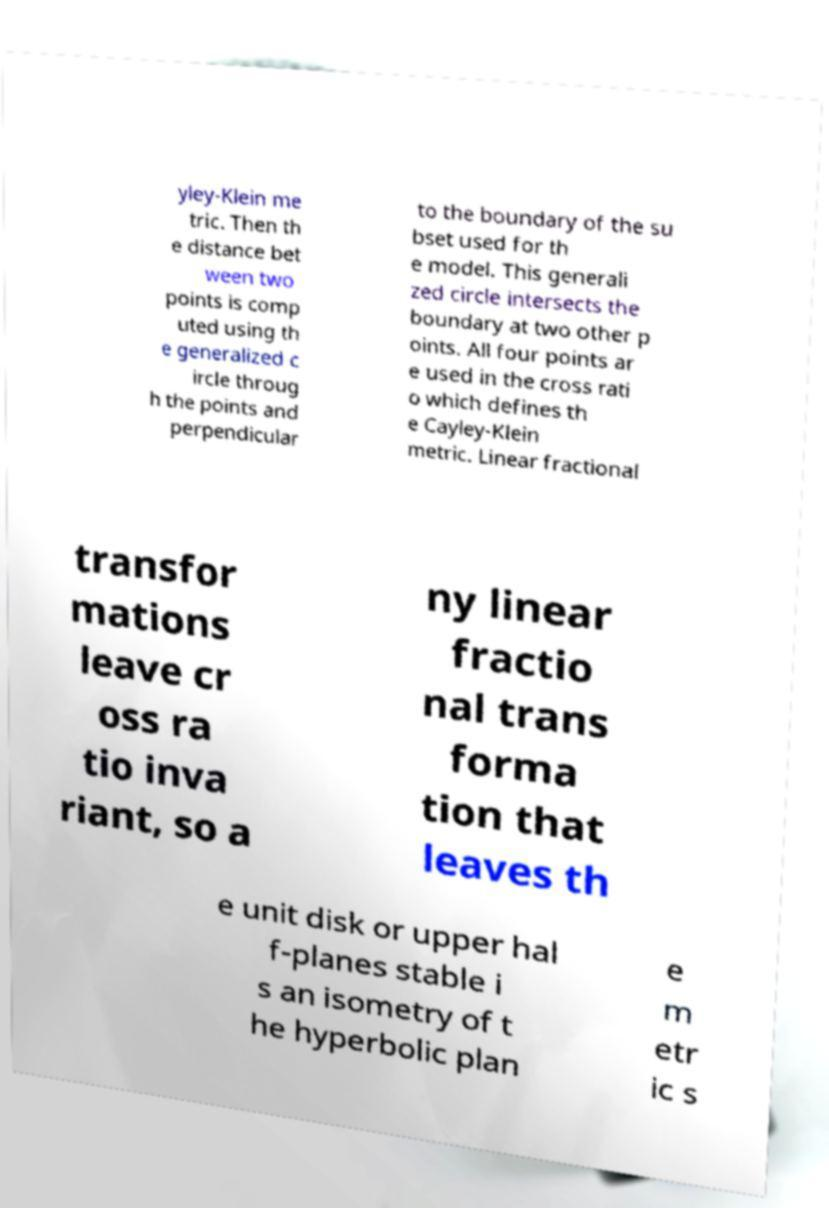For documentation purposes, I need the text within this image transcribed. Could you provide that? yley-Klein me tric. Then th e distance bet ween two points is comp uted using th e generalized c ircle throug h the points and perpendicular to the boundary of the su bset used for th e model. This generali zed circle intersects the boundary at two other p oints. All four points ar e used in the cross rati o which defines th e Cayley-Klein metric. Linear fractional transfor mations leave cr oss ra tio inva riant, so a ny linear fractio nal trans forma tion that leaves th e unit disk or upper hal f-planes stable i s an isometry of t he hyperbolic plan e m etr ic s 